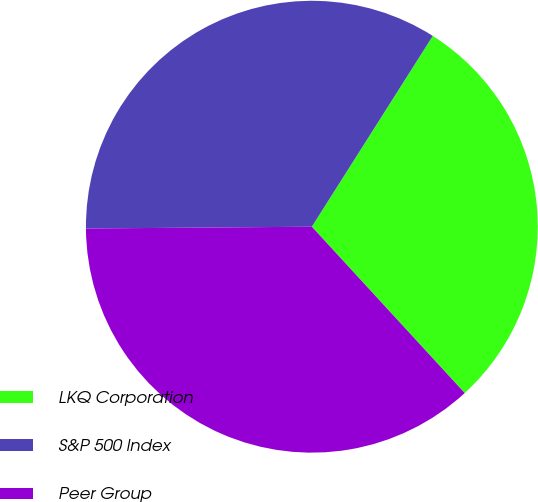<chart> <loc_0><loc_0><loc_500><loc_500><pie_chart><fcel>LKQ Corporation<fcel>S&P 500 Index<fcel>Peer Group<nl><fcel>29.18%<fcel>34.12%<fcel>36.71%<nl></chart> 